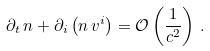Convert formula to latex. <formula><loc_0><loc_0><loc_500><loc_500>\partial _ { t } \, n + \partial _ { i } \left ( n \, v ^ { i } \right ) = \mathcal { O } \left ( \frac { 1 } { c ^ { 2 } } \right ) \, .</formula> 